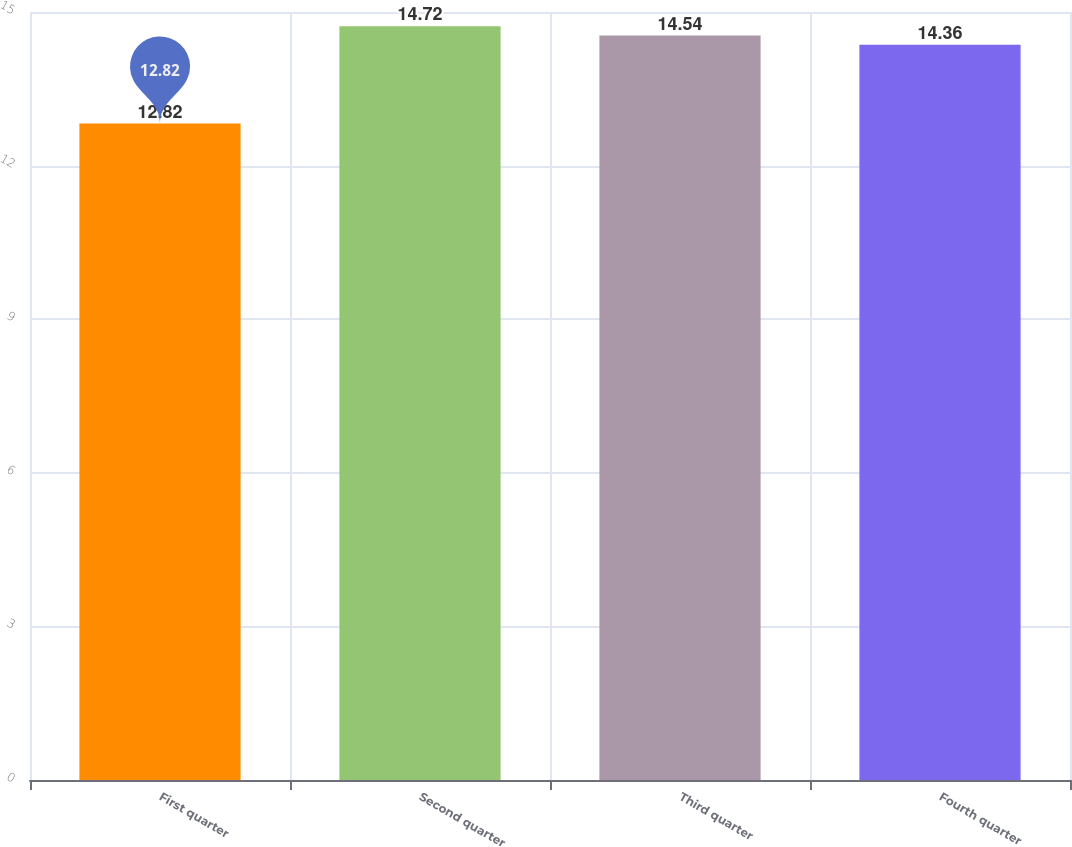Convert chart to OTSL. <chart><loc_0><loc_0><loc_500><loc_500><bar_chart><fcel>First quarter<fcel>Second quarter<fcel>Third quarter<fcel>Fourth quarter<nl><fcel>12.82<fcel>14.72<fcel>14.54<fcel>14.36<nl></chart> 